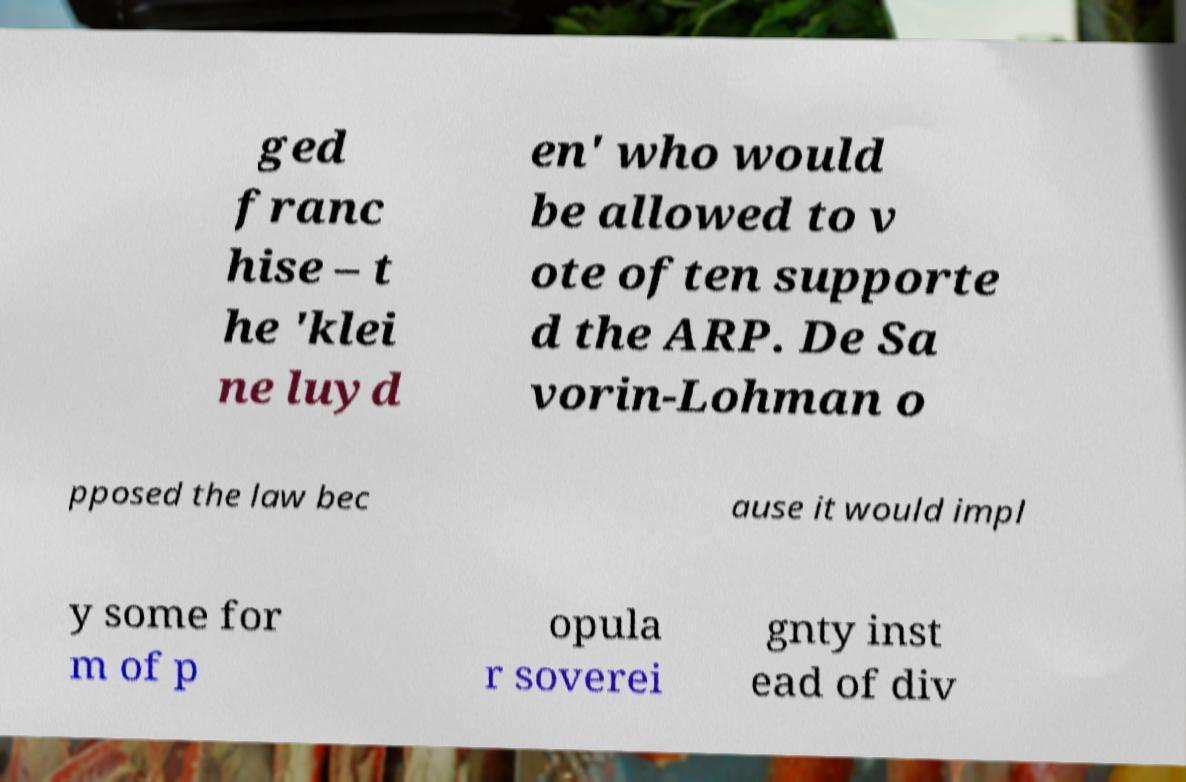I need the written content from this picture converted into text. Can you do that? ged franc hise – t he 'klei ne luyd en' who would be allowed to v ote often supporte d the ARP. De Sa vorin-Lohman o pposed the law bec ause it would impl y some for m of p opula r soverei gnty inst ead of div 